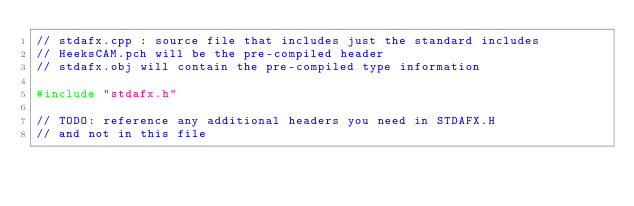<code> <loc_0><loc_0><loc_500><loc_500><_C++_>// stdafx.cpp : source file that includes just the standard includes
// HeeksCAM.pch will be the pre-compiled header
// stdafx.obj will contain the pre-compiled type information

#include "stdafx.h"

// TODO: reference any additional headers you need in STDAFX.H
// and not in this file
</code> 